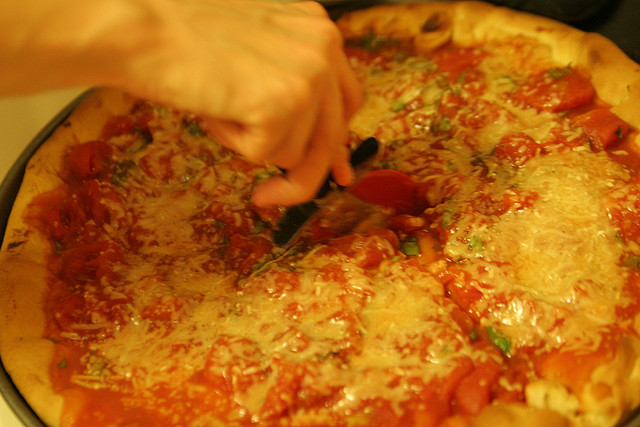<image>What type of meat is pictured? It is ambiguous to specify the type of meat pictured. It could be pepperoni or none. What type of meat is pictured? I am not sure what type of meat is pictured. It can be seen as 'pepperoni' or 'none'. 